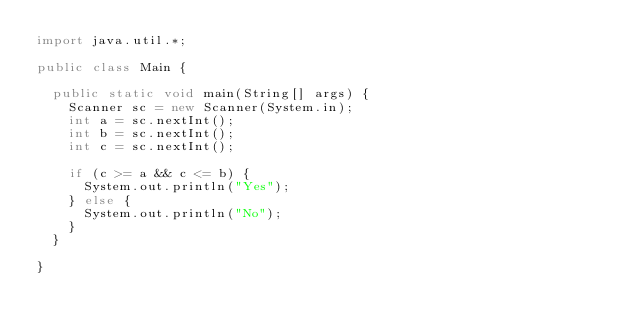<code> <loc_0><loc_0><loc_500><loc_500><_Java_>import java.util.*;

public class Main {

  public static void main(String[] args) {
    Scanner sc = new Scanner(System.in);
    int a = sc.nextInt();
    int b = sc.nextInt();
    int c = sc.nextInt();

    if (c >= a && c <= b) {
      System.out.println("Yes");
    } else {
      System.out.println("No");
    }
  }

}
</code> 